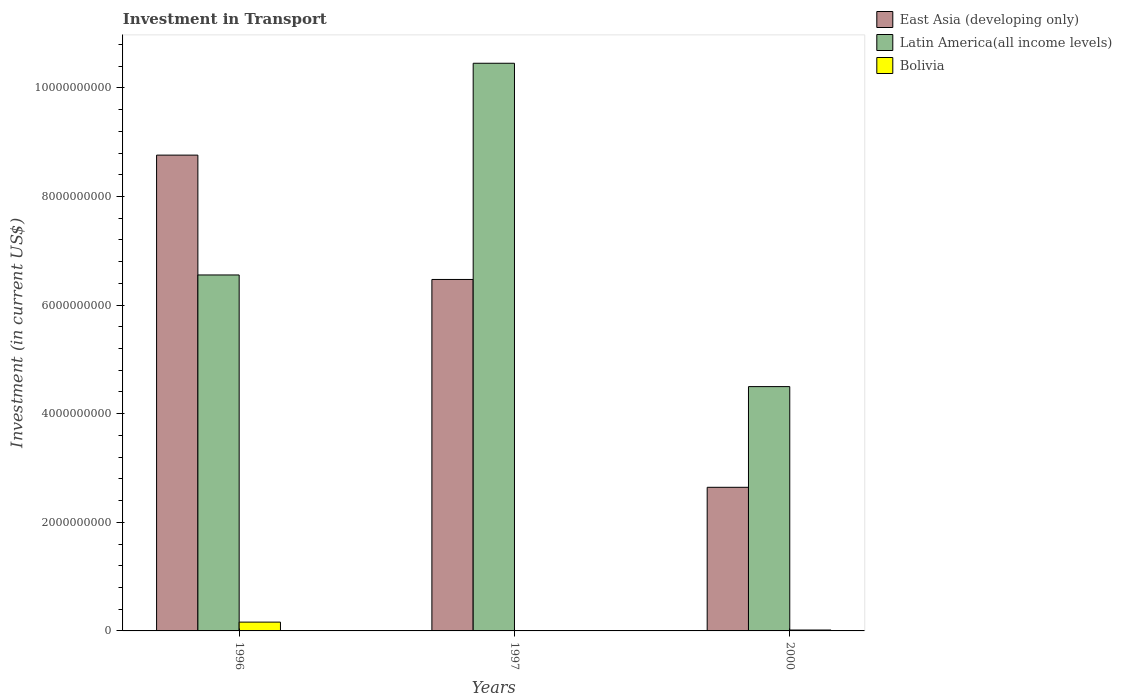How many different coloured bars are there?
Provide a succinct answer. 3. How many groups of bars are there?
Keep it short and to the point. 3. Are the number of bars per tick equal to the number of legend labels?
Your response must be concise. Yes. Are the number of bars on each tick of the X-axis equal?
Offer a terse response. Yes. In how many cases, is the number of bars for a given year not equal to the number of legend labels?
Your response must be concise. 0. What is the amount invested in transport in East Asia (developing only) in 2000?
Offer a very short reply. 2.64e+09. Across all years, what is the maximum amount invested in transport in East Asia (developing only)?
Your answer should be compact. 8.76e+09. Across all years, what is the minimum amount invested in transport in East Asia (developing only)?
Offer a very short reply. 2.64e+09. In which year was the amount invested in transport in East Asia (developing only) maximum?
Provide a short and direct response. 1996. In which year was the amount invested in transport in Bolivia minimum?
Your answer should be very brief. 1997. What is the total amount invested in transport in Latin America(all income levels) in the graph?
Give a very brief answer. 2.15e+1. What is the difference between the amount invested in transport in East Asia (developing only) in 1996 and that in 2000?
Offer a terse response. 6.12e+09. What is the difference between the amount invested in transport in East Asia (developing only) in 2000 and the amount invested in transport in Latin America(all income levels) in 1996?
Provide a short and direct response. -3.91e+09. What is the average amount invested in transport in East Asia (developing only) per year?
Provide a succinct answer. 5.96e+09. In the year 2000, what is the difference between the amount invested in transport in Latin America(all income levels) and amount invested in transport in Bolivia?
Provide a short and direct response. 4.48e+09. What is the ratio of the amount invested in transport in Bolivia in 1996 to that in 1997?
Offer a terse response. 24.56. Is the amount invested in transport in Bolivia in 1997 less than that in 2000?
Offer a very short reply. Yes. What is the difference between the highest and the second highest amount invested in transport in East Asia (developing only)?
Make the answer very short. 2.29e+09. What is the difference between the highest and the lowest amount invested in transport in East Asia (developing only)?
Your answer should be very brief. 6.12e+09. In how many years, is the amount invested in transport in East Asia (developing only) greater than the average amount invested in transport in East Asia (developing only) taken over all years?
Your response must be concise. 2. What does the 2nd bar from the left in 2000 represents?
Your answer should be compact. Latin America(all income levels). What does the 3rd bar from the right in 1996 represents?
Provide a short and direct response. East Asia (developing only). Is it the case that in every year, the sum of the amount invested in transport in Latin America(all income levels) and amount invested in transport in East Asia (developing only) is greater than the amount invested in transport in Bolivia?
Your response must be concise. Yes. How many bars are there?
Ensure brevity in your answer.  9. Are all the bars in the graph horizontal?
Offer a very short reply. No. Does the graph contain grids?
Provide a short and direct response. No. How are the legend labels stacked?
Offer a very short reply. Vertical. What is the title of the graph?
Provide a succinct answer. Investment in Transport. What is the label or title of the X-axis?
Keep it short and to the point. Years. What is the label or title of the Y-axis?
Your answer should be very brief. Investment (in current US$). What is the Investment (in current US$) in East Asia (developing only) in 1996?
Keep it short and to the point. 8.76e+09. What is the Investment (in current US$) of Latin America(all income levels) in 1996?
Offer a terse response. 6.55e+09. What is the Investment (in current US$) of Bolivia in 1996?
Your response must be concise. 1.62e+08. What is the Investment (in current US$) of East Asia (developing only) in 1997?
Your response must be concise. 6.47e+09. What is the Investment (in current US$) of Latin America(all income levels) in 1997?
Give a very brief answer. 1.05e+1. What is the Investment (in current US$) in Bolivia in 1997?
Offer a terse response. 6.60e+06. What is the Investment (in current US$) of East Asia (developing only) in 2000?
Provide a short and direct response. 2.64e+09. What is the Investment (in current US$) in Latin America(all income levels) in 2000?
Provide a succinct answer. 4.50e+09. What is the Investment (in current US$) of Bolivia in 2000?
Make the answer very short. 1.66e+07. Across all years, what is the maximum Investment (in current US$) in East Asia (developing only)?
Your answer should be compact. 8.76e+09. Across all years, what is the maximum Investment (in current US$) in Latin America(all income levels)?
Provide a short and direct response. 1.05e+1. Across all years, what is the maximum Investment (in current US$) in Bolivia?
Offer a very short reply. 1.62e+08. Across all years, what is the minimum Investment (in current US$) in East Asia (developing only)?
Make the answer very short. 2.64e+09. Across all years, what is the minimum Investment (in current US$) in Latin America(all income levels)?
Your response must be concise. 4.50e+09. Across all years, what is the minimum Investment (in current US$) of Bolivia?
Offer a terse response. 6.60e+06. What is the total Investment (in current US$) of East Asia (developing only) in the graph?
Offer a terse response. 1.79e+1. What is the total Investment (in current US$) in Latin America(all income levels) in the graph?
Make the answer very short. 2.15e+1. What is the total Investment (in current US$) of Bolivia in the graph?
Provide a short and direct response. 1.85e+08. What is the difference between the Investment (in current US$) in East Asia (developing only) in 1996 and that in 1997?
Provide a short and direct response. 2.29e+09. What is the difference between the Investment (in current US$) of Latin America(all income levels) in 1996 and that in 1997?
Ensure brevity in your answer.  -3.90e+09. What is the difference between the Investment (in current US$) of Bolivia in 1996 and that in 1997?
Make the answer very short. 1.56e+08. What is the difference between the Investment (in current US$) in East Asia (developing only) in 1996 and that in 2000?
Ensure brevity in your answer.  6.12e+09. What is the difference between the Investment (in current US$) of Latin America(all income levels) in 1996 and that in 2000?
Provide a succinct answer. 2.06e+09. What is the difference between the Investment (in current US$) of Bolivia in 1996 and that in 2000?
Your answer should be compact. 1.46e+08. What is the difference between the Investment (in current US$) of East Asia (developing only) in 1997 and that in 2000?
Your answer should be compact. 3.83e+09. What is the difference between the Investment (in current US$) in Latin America(all income levels) in 1997 and that in 2000?
Keep it short and to the point. 5.95e+09. What is the difference between the Investment (in current US$) in Bolivia in 1997 and that in 2000?
Give a very brief answer. -1.00e+07. What is the difference between the Investment (in current US$) in East Asia (developing only) in 1996 and the Investment (in current US$) in Latin America(all income levels) in 1997?
Your response must be concise. -1.69e+09. What is the difference between the Investment (in current US$) of East Asia (developing only) in 1996 and the Investment (in current US$) of Bolivia in 1997?
Keep it short and to the point. 8.75e+09. What is the difference between the Investment (in current US$) in Latin America(all income levels) in 1996 and the Investment (in current US$) in Bolivia in 1997?
Your answer should be compact. 6.55e+09. What is the difference between the Investment (in current US$) in East Asia (developing only) in 1996 and the Investment (in current US$) in Latin America(all income levels) in 2000?
Your answer should be compact. 4.26e+09. What is the difference between the Investment (in current US$) of East Asia (developing only) in 1996 and the Investment (in current US$) of Bolivia in 2000?
Your answer should be very brief. 8.74e+09. What is the difference between the Investment (in current US$) in Latin America(all income levels) in 1996 and the Investment (in current US$) in Bolivia in 2000?
Your answer should be very brief. 6.54e+09. What is the difference between the Investment (in current US$) in East Asia (developing only) in 1997 and the Investment (in current US$) in Latin America(all income levels) in 2000?
Keep it short and to the point. 1.97e+09. What is the difference between the Investment (in current US$) of East Asia (developing only) in 1997 and the Investment (in current US$) of Bolivia in 2000?
Provide a succinct answer. 6.46e+09. What is the difference between the Investment (in current US$) in Latin America(all income levels) in 1997 and the Investment (in current US$) in Bolivia in 2000?
Offer a very short reply. 1.04e+1. What is the average Investment (in current US$) of East Asia (developing only) per year?
Make the answer very short. 5.96e+09. What is the average Investment (in current US$) in Latin America(all income levels) per year?
Your response must be concise. 7.17e+09. What is the average Investment (in current US$) of Bolivia per year?
Give a very brief answer. 6.18e+07. In the year 1996, what is the difference between the Investment (in current US$) in East Asia (developing only) and Investment (in current US$) in Latin America(all income levels)?
Provide a short and direct response. 2.21e+09. In the year 1996, what is the difference between the Investment (in current US$) in East Asia (developing only) and Investment (in current US$) in Bolivia?
Make the answer very short. 8.60e+09. In the year 1996, what is the difference between the Investment (in current US$) of Latin America(all income levels) and Investment (in current US$) of Bolivia?
Offer a terse response. 6.39e+09. In the year 1997, what is the difference between the Investment (in current US$) of East Asia (developing only) and Investment (in current US$) of Latin America(all income levels)?
Offer a very short reply. -3.98e+09. In the year 1997, what is the difference between the Investment (in current US$) of East Asia (developing only) and Investment (in current US$) of Bolivia?
Your answer should be very brief. 6.47e+09. In the year 1997, what is the difference between the Investment (in current US$) in Latin America(all income levels) and Investment (in current US$) in Bolivia?
Ensure brevity in your answer.  1.04e+1. In the year 2000, what is the difference between the Investment (in current US$) in East Asia (developing only) and Investment (in current US$) in Latin America(all income levels)?
Ensure brevity in your answer.  -1.85e+09. In the year 2000, what is the difference between the Investment (in current US$) of East Asia (developing only) and Investment (in current US$) of Bolivia?
Your answer should be compact. 2.63e+09. In the year 2000, what is the difference between the Investment (in current US$) of Latin America(all income levels) and Investment (in current US$) of Bolivia?
Your answer should be compact. 4.48e+09. What is the ratio of the Investment (in current US$) of East Asia (developing only) in 1996 to that in 1997?
Provide a succinct answer. 1.35. What is the ratio of the Investment (in current US$) of Latin America(all income levels) in 1996 to that in 1997?
Provide a succinct answer. 0.63. What is the ratio of the Investment (in current US$) of Bolivia in 1996 to that in 1997?
Keep it short and to the point. 24.56. What is the ratio of the Investment (in current US$) in East Asia (developing only) in 1996 to that in 2000?
Your answer should be very brief. 3.31. What is the ratio of the Investment (in current US$) of Latin America(all income levels) in 1996 to that in 2000?
Give a very brief answer. 1.46. What is the ratio of the Investment (in current US$) of Bolivia in 1996 to that in 2000?
Your response must be concise. 9.77. What is the ratio of the Investment (in current US$) of East Asia (developing only) in 1997 to that in 2000?
Your answer should be compact. 2.45. What is the ratio of the Investment (in current US$) of Latin America(all income levels) in 1997 to that in 2000?
Your response must be concise. 2.32. What is the ratio of the Investment (in current US$) in Bolivia in 1997 to that in 2000?
Offer a terse response. 0.4. What is the difference between the highest and the second highest Investment (in current US$) of East Asia (developing only)?
Keep it short and to the point. 2.29e+09. What is the difference between the highest and the second highest Investment (in current US$) in Latin America(all income levels)?
Your answer should be very brief. 3.90e+09. What is the difference between the highest and the second highest Investment (in current US$) in Bolivia?
Offer a terse response. 1.46e+08. What is the difference between the highest and the lowest Investment (in current US$) of East Asia (developing only)?
Give a very brief answer. 6.12e+09. What is the difference between the highest and the lowest Investment (in current US$) in Latin America(all income levels)?
Offer a terse response. 5.95e+09. What is the difference between the highest and the lowest Investment (in current US$) in Bolivia?
Your answer should be very brief. 1.56e+08. 